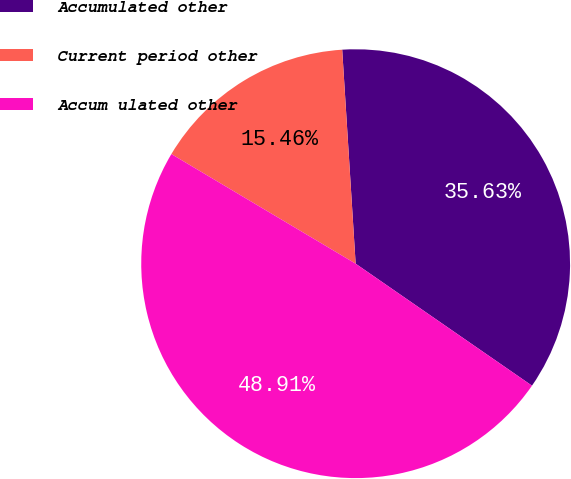<chart> <loc_0><loc_0><loc_500><loc_500><pie_chart><fcel>Accumulated other<fcel>Current period other<fcel>Accum ulated other<nl><fcel>35.63%<fcel>15.46%<fcel>48.91%<nl></chart> 